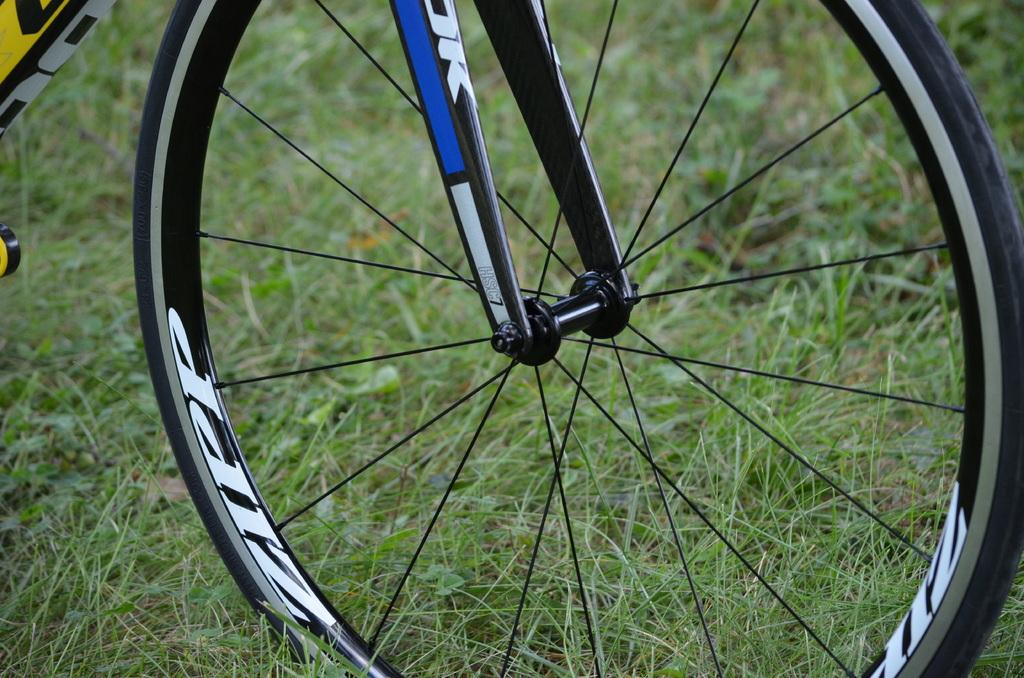What object is on the ground in the image? There is a bicycle on the ground in the image. What type of terrain is visible in the background of the image? There is grass visible in the background of the image. What type of mountain can be seen in the background of the image? There is no mountain visible in the background of the image; it features grass. What kind of test is being conducted on the bicycle in the image? There is no test being conducted on the bicycle in the image; it is simply on the ground. 